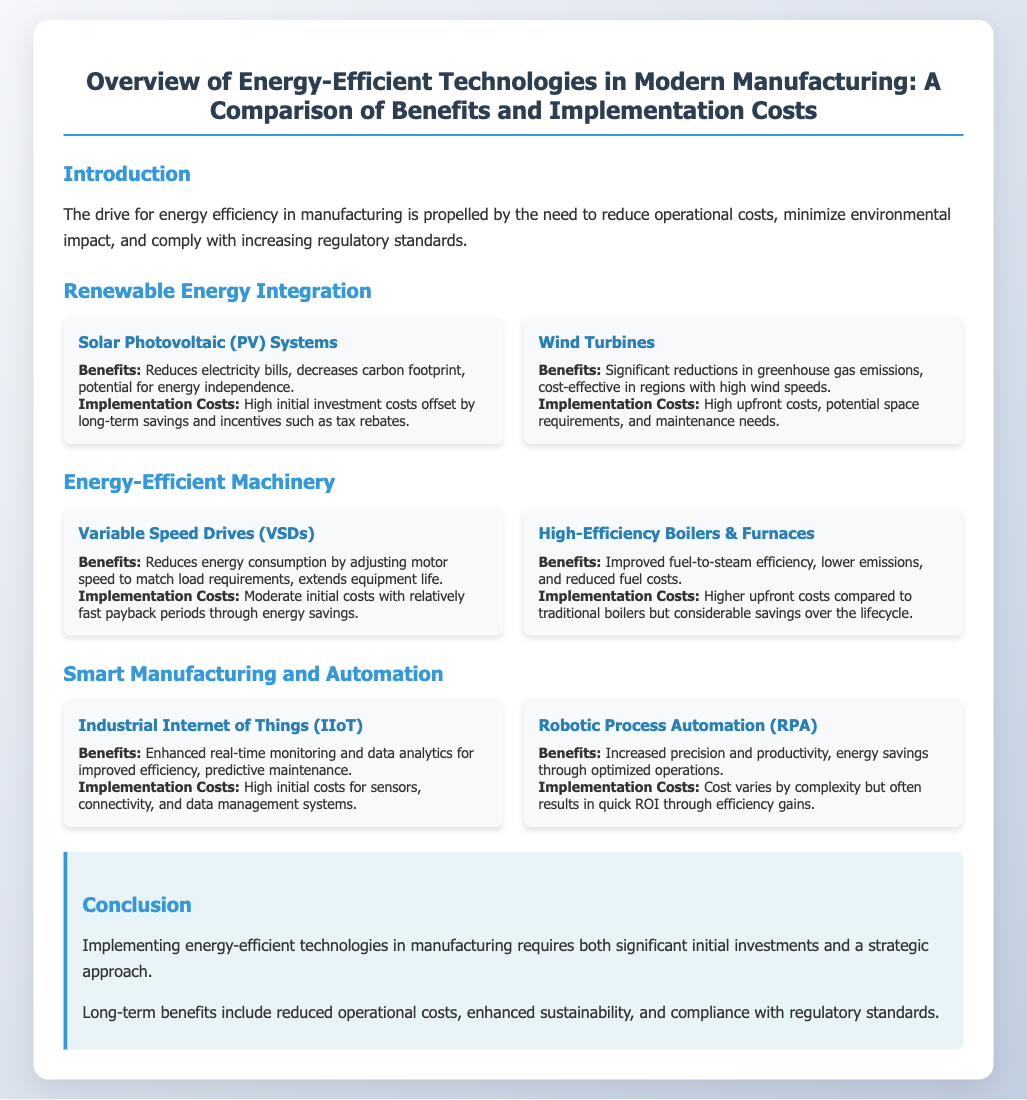what are the main drivers for energy efficiency in manufacturing? The introduction states that the drive for energy efficiency is propelled by the need to reduce operational costs, minimize environmental impact, and comply with increasing regulatory standards.
Answer: operational costs, environmental impact, regulatory standards what is a key benefit of Solar Photovoltaic (PV) Systems? The document mentions one of the key benefits is reducing electricity bills.
Answer: reducing electricity bills what is the implementation cost classification of Variable Speed Drives (VSDs)? According to the document, Variable Speed Drives (VSDs) have moderate initial costs with relatively fast payback periods through energy savings.
Answer: moderate initial costs what technology is associated with enhanced real-time monitoring and predictive maintenance? The technology mentioned in the document related to enhanced real-time monitoring and predictive maintenance is the Industrial Internet of Things (IIoT).
Answer: Industrial Internet of Things (IIoT) which technology offers energy savings through optimized operations? The document states that Robotic Process Automation (RPA) offers energy savings through optimized operations.
Answer: Robotic Process Automation (RPA) what does the conclusion highlight about implementing energy-efficient technologies? The conclusion highlights that implementing energy-efficient technologies requires significant initial investments and a strategic approach.
Answer: significant initial investments and a strategic approach how does the implementation of high-efficiency boilers & furnaces compare to traditional boilers? The document indicates that high-efficiency boilers & furnaces have higher upfront costs but considerable savings over the lifecycle compared to traditional boilers.
Answer: higher upfront costs what type of costs are associated with Wind Turbines? The implementation costs for Wind Turbines are described as high upfront costs, potential space requirements, and maintenance needs.
Answer: high upfront costs what is the potential environmental benefit of integrating wind turbines? The document states that integrating wind turbines results in significant reductions in greenhouse gas emissions.
Answer: significant reductions in greenhouse gas emissions 